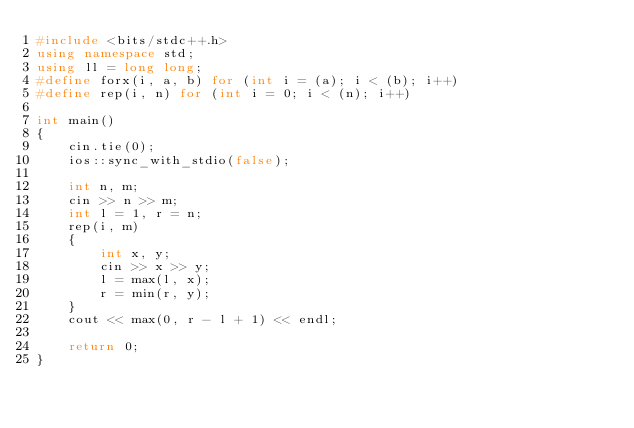<code> <loc_0><loc_0><loc_500><loc_500><_C++_>#include <bits/stdc++.h>
using namespace std;
using ll = long long;
#define forx(i, a, b) for (int i = (a); i < (b); i++)
#define rep(i, n) for (int i = 0; i < (n); i++)

int main()
{
    cin.tie(0);
    ios::sync_with_stdio(false);

    int n, m;
    cin >> n >> m;
    int l = 1, r = n;
    rep(i, m)
    {
        int x, y;
        cin >> x >> y;
        l = max(l, x);
        r = min(r, y);
    }
    cout << max(0, r - l + 1) << endl;

    return 0;
}
</code> 